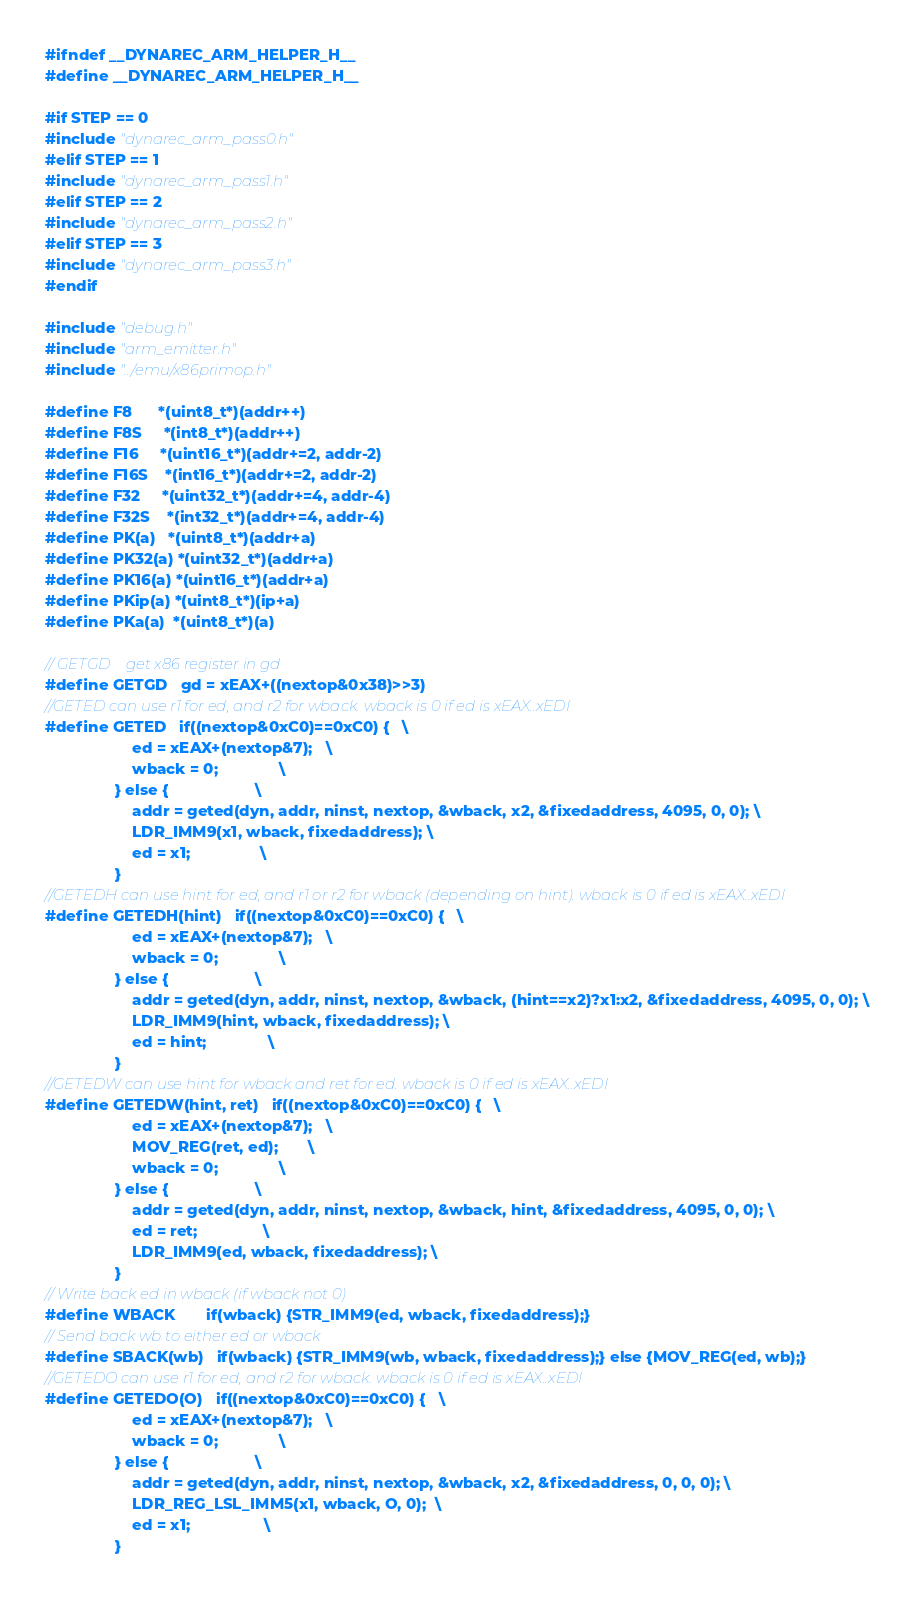<code> <loc_0><loc_0><loc_500><loc_500><_C_>#ifndef __DYNAREC_ARM_HELPER_H__
#define __DYNAREC_ARM_HELPER_H__

#if STEP == 0
#include "dynarec_arm_pass0.h"
#elif STEP == 1
#include "dynarec_arm_pass1.h"
#elif STEP == 2
#include "dynarec_arm_pass2.h"
#elif STEP == 3
#include "dynarec_arm_pass3.h"
#endif

#include "debug.h"
#include "arm_emitter.h"
#include "../emu/x86primop.h"

#define F8      *(uint8_t*)(addr++)
#define F8S     *(int8_t*)(addr++)
#define F16     *(uint16_t*)(addr+=2, addr-2)
#define F16S    *(int16_t*)(addr+=2, addr-2)
#define F32     *(uint32_t*)(addr+=4, addr-4)
#define F32S    *(int32_t*)(addr+=4, addr-4)
#define PK(a)   *(uint8_t*)(addr+a)
#define PK32(a) *(uint32_t*)(addr+a)
#define PK16(a) *(uint16_t*)(addr+a)
#define PKip(a) *(uint8_t*)(ip+a)
#define PKa(a)  *(uint8_t*)(a)

// GETGD    get x86 register in gd
#define GETGD   gd = xEAX+((nextop&0x38)>>3)
//GETED can use r1 for ed, and r2 for wback. wback is 0 if ed is xEAX..xEDI
#define GETED   if((nextop&0xC0)==0xC0) {   \
                    ed = xEAX+(nextop&7);   \
                    wback = 0;              \
                } else {                    \
                    addr = geted(dyn, addr, ninst, nextop, &wback, x2, &fixedaddress, 4095, 0, 0); \
                    LDR_IMM9(x1, wback, fixedaddress); \
                    ed = x1;                \
                }
//GETEDH can use hint for ed, and r1 or r2 for wback (depending on hint). wback is 0 if ed is xEAX..xEDI
#define GETEDH(hint)   if((nextop&0xC0)==0xC0) {   \
                    ed = xEAX+(nextop&7);   \
                    wback = 0;              \
                } else {                    \
                    addr = geted(dyn, addr, ninst, nextop, &wback, (hint==x2)?x1:x2, &fixedaddress, 4095, 0, 0); \
                    LDR_IMM9(hint, wback, fixedaddress); \
                    ed = hint;              \
                }
//GETEDW can use hint for wback and ret for ed. wback is 0 if ed is xEAX..xEDI
#define GETEDW(hint, ret)   if((nextop&0xC0)==0xC0) {   \
                    ed = xEAX+(nextop&7);   \
                    MOV_REG(ret, ed);       \
                    wback = 0;              \
                } else {                    \
                    addr = geted(dyn, addr, ninst, nextop, &wback, hint, &fixedaddress, 4095, 0, 0); \
                    ed = ret;               \
                    LDR_IMM9(ed, wback, fixedaddress); \
                }
// Write back ed in wback (if wback not 0)
#define WBACK       if(wback) {STR_IMM9(ed, wback, fixedaddress);}
// Send back wb to either ed or wback
#define SBACK(wb)   if(wback) {STR_IMM9(wb, wback, fixedaddress);} else {MOV_REG(ed, wb);}
//GETEDO can use r1 for ed, and r2 for wback. wback is 0 if ed is xEAX..xEDI
#define GETEDO(O)   if((nextop&0xC0)==0xC0) {   \
                    ed = xEAX+(nextop&7);   \
                    wback = 0;              \
                } else {                    \
                    addr = geted(dyn, addr, ninst, nextop, &wback, x2, &fixedaddress, 0, 0, 0); \
                    LDR_REG_LSL_IMM5(x1, wback, O, 0);  \
                    ed = x1;                 \
                }</code> 